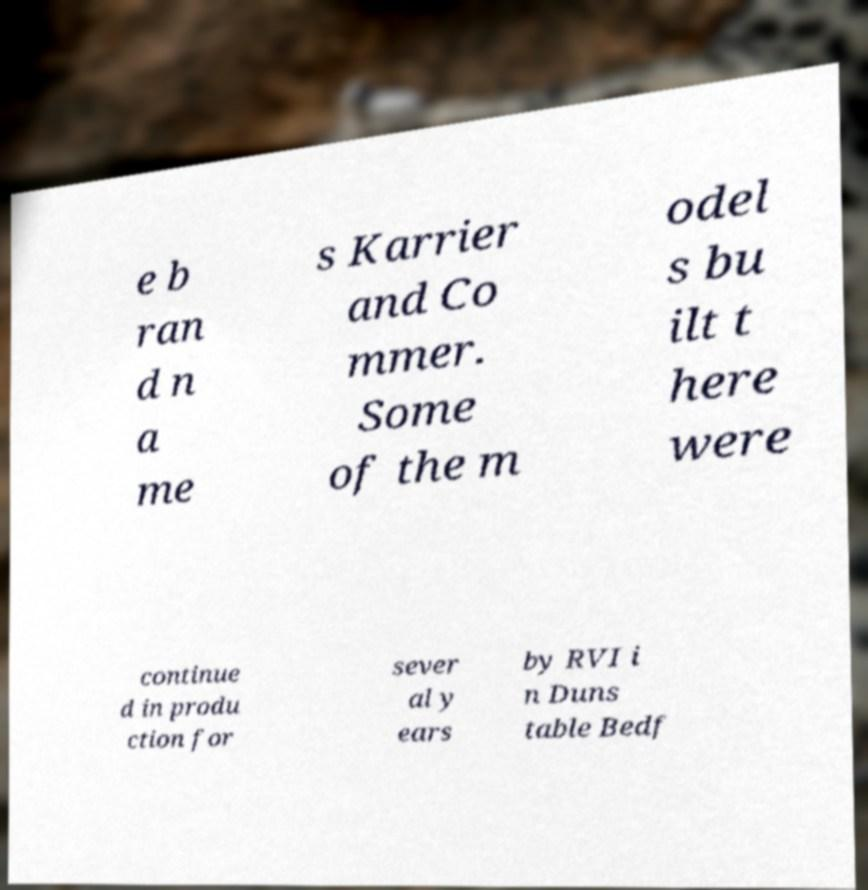There's text embedded in this image that I need extracted. Can you transcribe it verbatim? e b ran d n a me s Karrier and Co mmer. Some of the m odel s bu ilt t here were continue d in produ ction for sever al y ears by RVI i n Duns table Bedf 